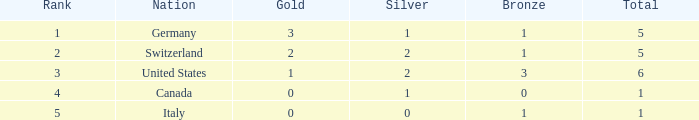How many golds for territories with in excess of 0 silvers, over 1 total, and beyond 3 bronzes? 0.0. 